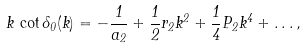Convert formula to latex. <formula><loc_0><loc_0><loc_500><loc_500>k \, \cot \delta _ { 0 } ( k ) = - \frac { 1 } { a _ { 2 } } + \frac { 1 } { 2 } r _ { 2 } k ^ { 2 } + \frac { 1 } { 4 } P _ { 2 } k ^ { 4 } + \dots ,</formula> 